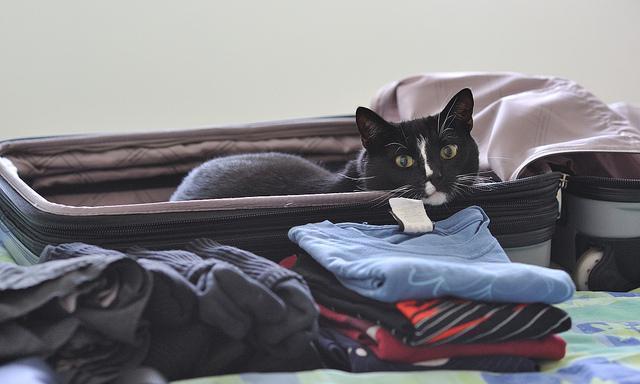How many shirts are in the stack?
Give a very brief answer. 4. 